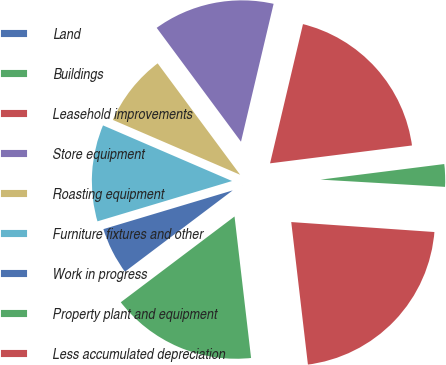<chart> <loc_0><loc_0><loc_500><loc_500><pie_chart><fcel>Land<fcel>Buildings<fcel>Leasehold improvements<fcel>Store equipment<fcel>Roasting equipment<fcel>Furniture fixtures and other<fcel>Work in progress<fcel>Property plant and equipment<fcel>Less accumulated depreciation<nl><fcel>0.18%<fcel>2.92%<fcel>19.31%<fcel>13.84%<fcel>8.38%<fcel>11.11%<fcel>5.65%<fcel>16.57%<fcel>22.04%<nl></chart> 